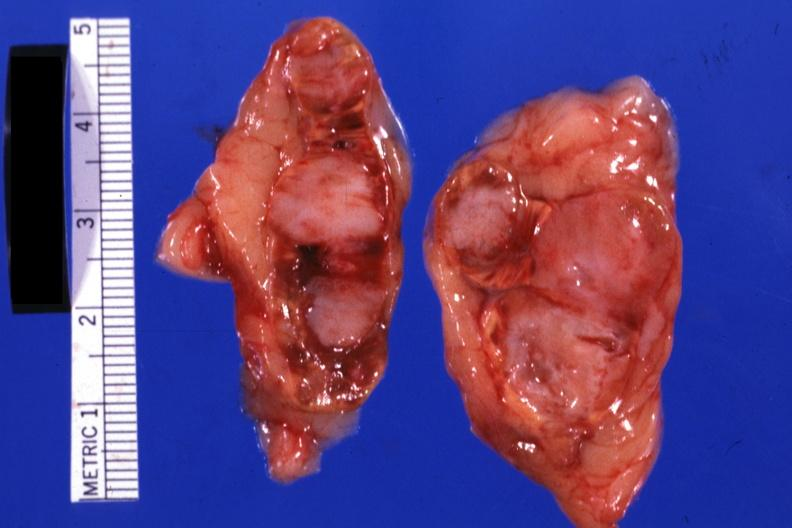where does this belong to?
Answer the question using a single word or phrase. Endocrine system 